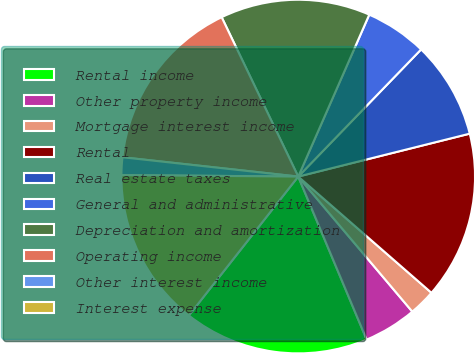<chart> <loc_0><loc_0><loc_500><loc_500><pie_chart><fcel>Rental income<fcel>Other property income<fcel>Mortgage interest income<fcel>Rental<fcel>Real estate taxes<fcel>General and administrative<fcel>Depreciation and amortization<fcel>Operating income<fcel>Other interest income<fcel>Interest expense<nl><fcel>16.94%<fcel>4.84%<fcel>2.42%<fcel>15.32%<fcel>8.87%<fcel>5.65%<fcel>13.71%<fcel>16.13%<fcel>1.61%<fcel>14.52%<nl></chart> 